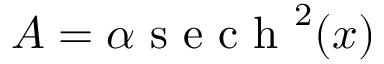Convert formula to latex. <formula><loc_0><loc_0><loc_500><loc_500>A = \alpha s e c h ^ { 2 } ( x )</formula> 